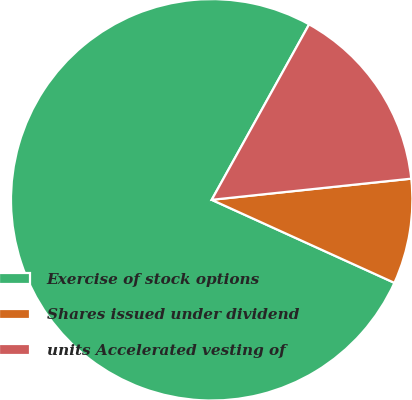Convert chart to OTSL. <chart><loc_0><loc_0><loc_500><loc_500><pie_chart><fcel>Exercise of stock options<fcel>Shares issued under dividend<fcel>units Accelerated vesting of<nl><fcel>76.27%<fcel>8.47%<fcel>15.25%<nl></chart> 